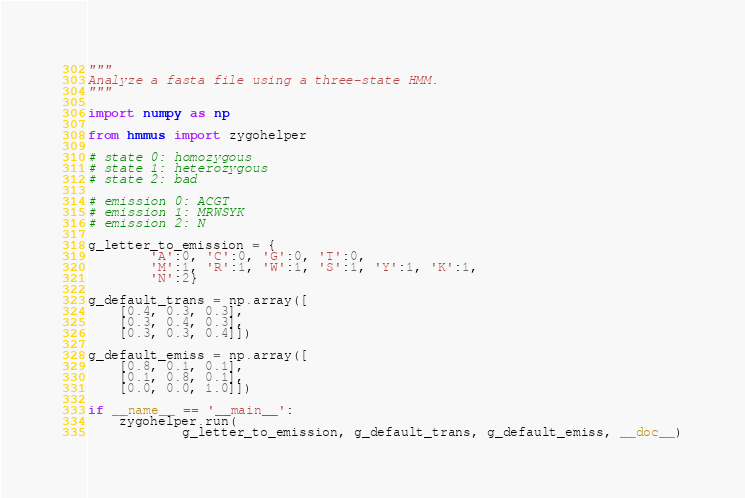Convert code to text. <code><loc_0><loc_0><loc_500><loc_500><_Python_>"""
Analyze a fasta file using a three-state HMM.
"""

import numpy as np

from hmmus import zygohelper

# state 0: homozygous
# state 1: heterozygous
# state 2: bad

# emission 0: ACGT
# emission 1: MRWSYK
# emission 2: N

g_letter_to_emission = {
        'A':0, 'C':0, 'G':0, 'T':0,
        'M':1, 'R':1, 'W':1, 'S':1, 'Y':1, 'K':1,
        'N':2}

g_default_trans = np.array([
    [0.4, 0.3, 0.3],
    [0.3, 0.4, 0.3],
    [0.3, 0.3, 0.4]])

g_default_emiss = np.array([
    [0.8, 0.1, 0.1],
    [0.1, 0.8, 0.1],
    [0.0, 0.0, 1.0]])

if __name__ == '__main__':
    zygohelper.run(
            g_letter_to_emission, g_default_trans, g_default_emiss, __doc__)
</code> 